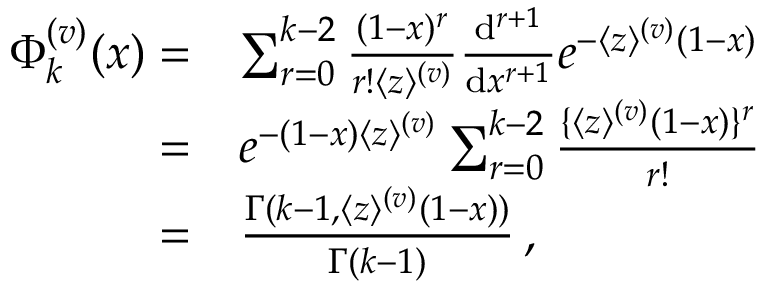<formula> <loc_0><loc_0><loc_500><loc_500>\begin{array} { r l } { \Phi _ { k } ^ { ( v ) } ( x ) = } & { \sum _ { r = 0 } ^ { k - 2 } \frac { ( 1 - x ) ^ { r } } { r ! \langle z \rangle ^ { ( v ) } } \frac { d ^ { r + 1 } } { d x ^ { r + 1 } } e ^ { - \langle z \rangle ^ { ( v ) } ( 1 - x ) } } \\ { = } & { e ^ { - ( 1 - x ) \langle z \rangle ^ { ( v ) } } \sum _ { r = 0 } ^ { k - 2 } \frac { \{ \langle z \rangle ^ { ( v ) } ( 1 - x ) \} ^ { r } } { r ! } } \\ { = } & { \frac { \Gamma ( k - 1 , \langle z \rangle ^ { ( v ) } ( 1 - x ) ) } { \Gamma ( k - 1 ) } \, , } \end{array}</formula> 